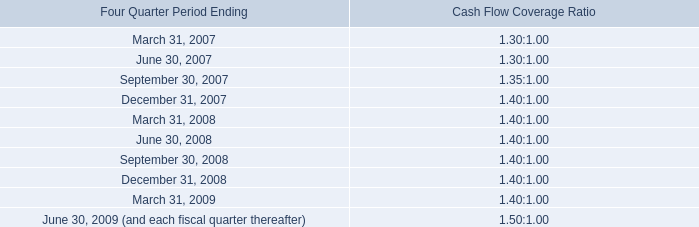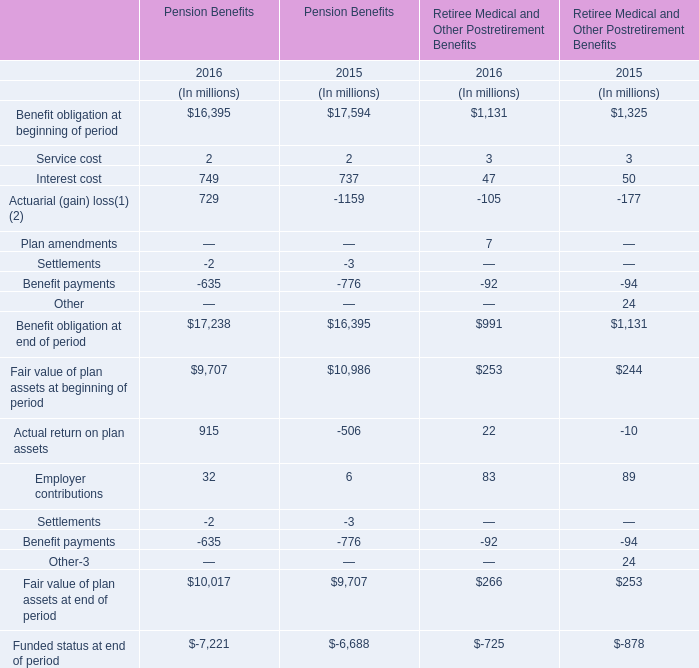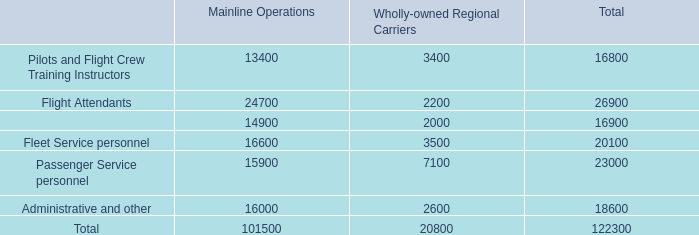If Pension Benefits' benefit obligation at beginning of period develops with the same increasing rate in 2016, what will it reach in 2017? (in million) 
Computations: (16395 * (1 + ((16395 - 17594) / 17594)))
Answer: 15277.70973. 